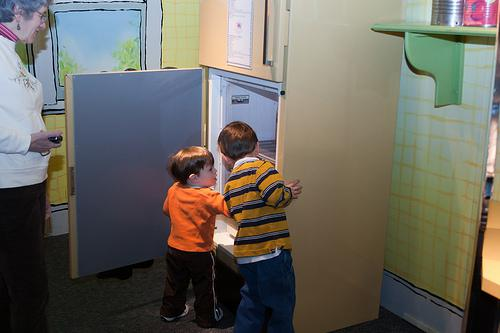Question: what are they looking for?
Choices:
A. Water.
B. Soda.
C. Snacks.
D. Food.
Answer with the letter. Answer: D 